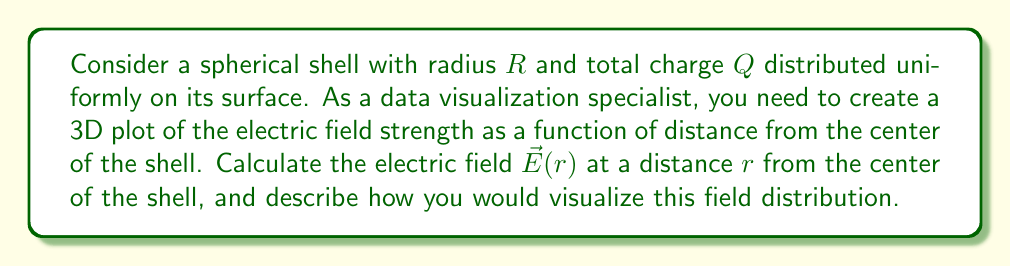Help me with this question. 1. We start with Gauss's law: $\oint \vec{E} \cdot d\vec{A} = \frac{Q_{enc}}{\epsilon_0}$

2. Due to spherical symmetry, the electric field will be radial and depend only on $r$:
   $\vec{E}(r) = E(r)\hat{r}$

3. For $r < R$:
   - $Q_{enc} = 0$ (no charge enclosed)
   - Therefore, $E(r) = 0$

4. For $r > R$:
   - $Q_{enc} = Q$ (all charge enclosed)
   - Gaussian surface area: $A = 4\pi r^2$
   - $4\pi r^2 E(r) = \frac{Q}{\epsilon_0}$
   - $E(r) = \frac{Q}{4\pi\epsilon_0 r^2}$

5. For $r = R$:
   - The field is discontinuous, jumping from 0 to $\frac{Q}{4\pi\epsilon_0 R^2}$

6. To visualize this:
   - Create a 3D plot with $x$, $y$, and $z$ axes
   - Use spherical coordinates $(r, \theta, \phi)$
   - For each point, calculate $E(r)$
   - Plot arrows representing $\vec{E}(r)$ with length proportional to magnitude
   - Color-code arrows based on field strength
   - Use a color gradient from blue (weak field) to red (strong field)
   - Ensure the shell at $r = R$ is clearly visible

7. The resulting visualization will show:
   - No arrows inside the shell
   - Arrows pointing radially outward outside the shell
   - Arrow length and color intensity decreasing with distance from the shell
Answer: $\vec{E}(r) = \begin{cases} 
0, & r < R \\
\frac{Q}{4\pi\epsilon_0 r^2}\hat{r}, & r > R
\end{cases}$ 